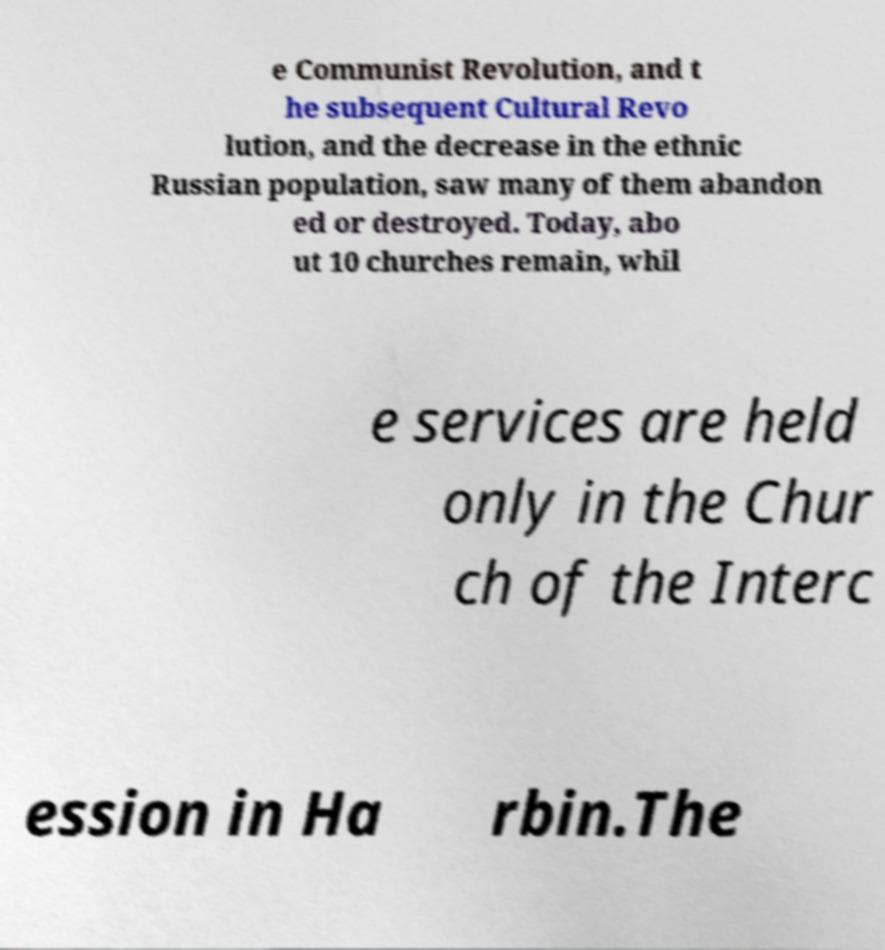Can you read and provide the text displayed in the image?This photo seems to have some interesting text. Can you extract and type it out for me? e Communist Revolution, and t he subsequent Cultural Revo lution, and the decrease in the ethnic Russian population, saw many of them abandon ed or destroyed. Today, abo ut 10 churches remain, whil e services are held only in the Chur ch of the Interc ession in Ha rbin.The 